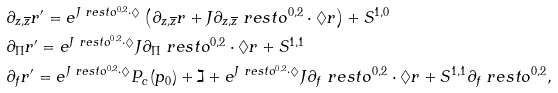Convert formula to latex. <formula><loc_0><loc_0><loc_500><loc_500>& \partial _ { z , \overline { z } } r ^ { \prime } = e ^ { J \ r e s t o ^ { 0 , 2 } \cdot \Diamond } \left ( \partial _ { z , \overline { z } } r + J \partial _ { z , \overline { z } } \ r e s t o ^ { 0 , 2 } \cdot \Diamond r \right ) + S ^ { 1 , 0 } \\ & \partial _ { \Pi } r ^ { \prime } = e ^ { J \ r e s t o ^ { 0 , 2 } \cdot \Diamond } J \partial _ { \Pi } \ r e s t o ^ { 0 , 2 } \cdot \Diamond r + S ^ { 1 , 1 } \\ & \partial _ { f } r ^ { \prime } = e ^ { J \ r e s t o ^ { 0 , 2 } \cdot \Diamond } P _ { c } ( p _ { 0 } ) + \gimel + e ^ { J \ r e s t o ^ { 0 , 2 } \cdot \Diamond } J \partial _ { f } \ r e s t o ^ { 0 , 2 } \cdot \Diamond r + S ^ { 1 , 1 } \partial _ { f } \ r e s t o ^ { 0 , 2 } ,</formula> 